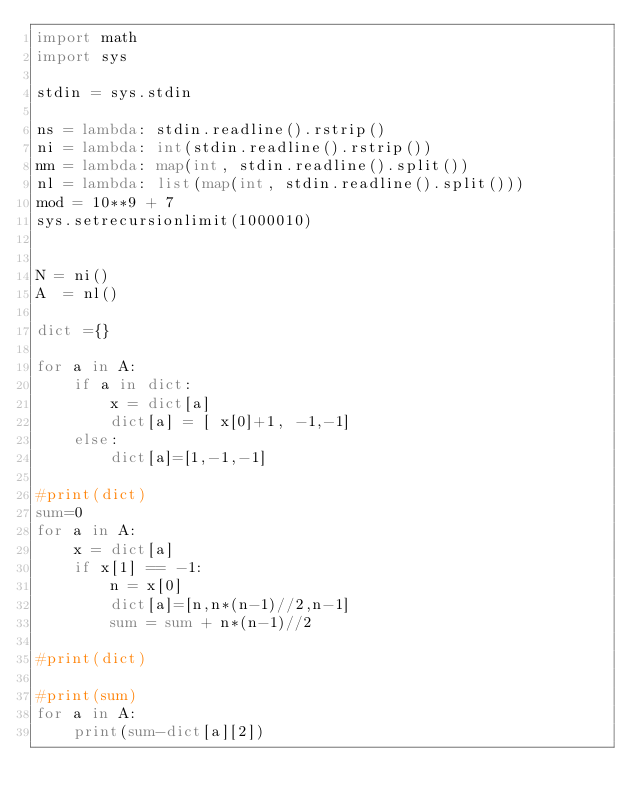<code> <loc_0><loc_0><loc_500><loc_500><_Python_>import math
import sys

stdin = sys.stdin

ns = lambda: stdin.readline().rstrip()
ni = lambda: int(stdin.readline().rstrip())
nm = lambda: map(int, stdin.readline().split())
nl = lambda: list(map(int, stdin.readline().split()))
mod = 10**9 + 7 
sys.setrecursionlimit(1000010)


N = ni()
A  = nl()

dict ={}

for a in A:
    if a in dict:
        x = dict[a]
        dict[a] = [ x[0]+1, -1,-1]        
    else:
        dict[a]=[1,-1,-1]

#print(dict)
sum=0
for a in A:
    x = dict[a]
    if x[1] == -1:
        n = x[0]
        dict[a]=[n,n*(n-1)//2,n-1]
        sum = sum + n*(n-1)//2

#print(dict)

#print(sum)
for a in A:
    print(sum-dict[a][2])

</code> 